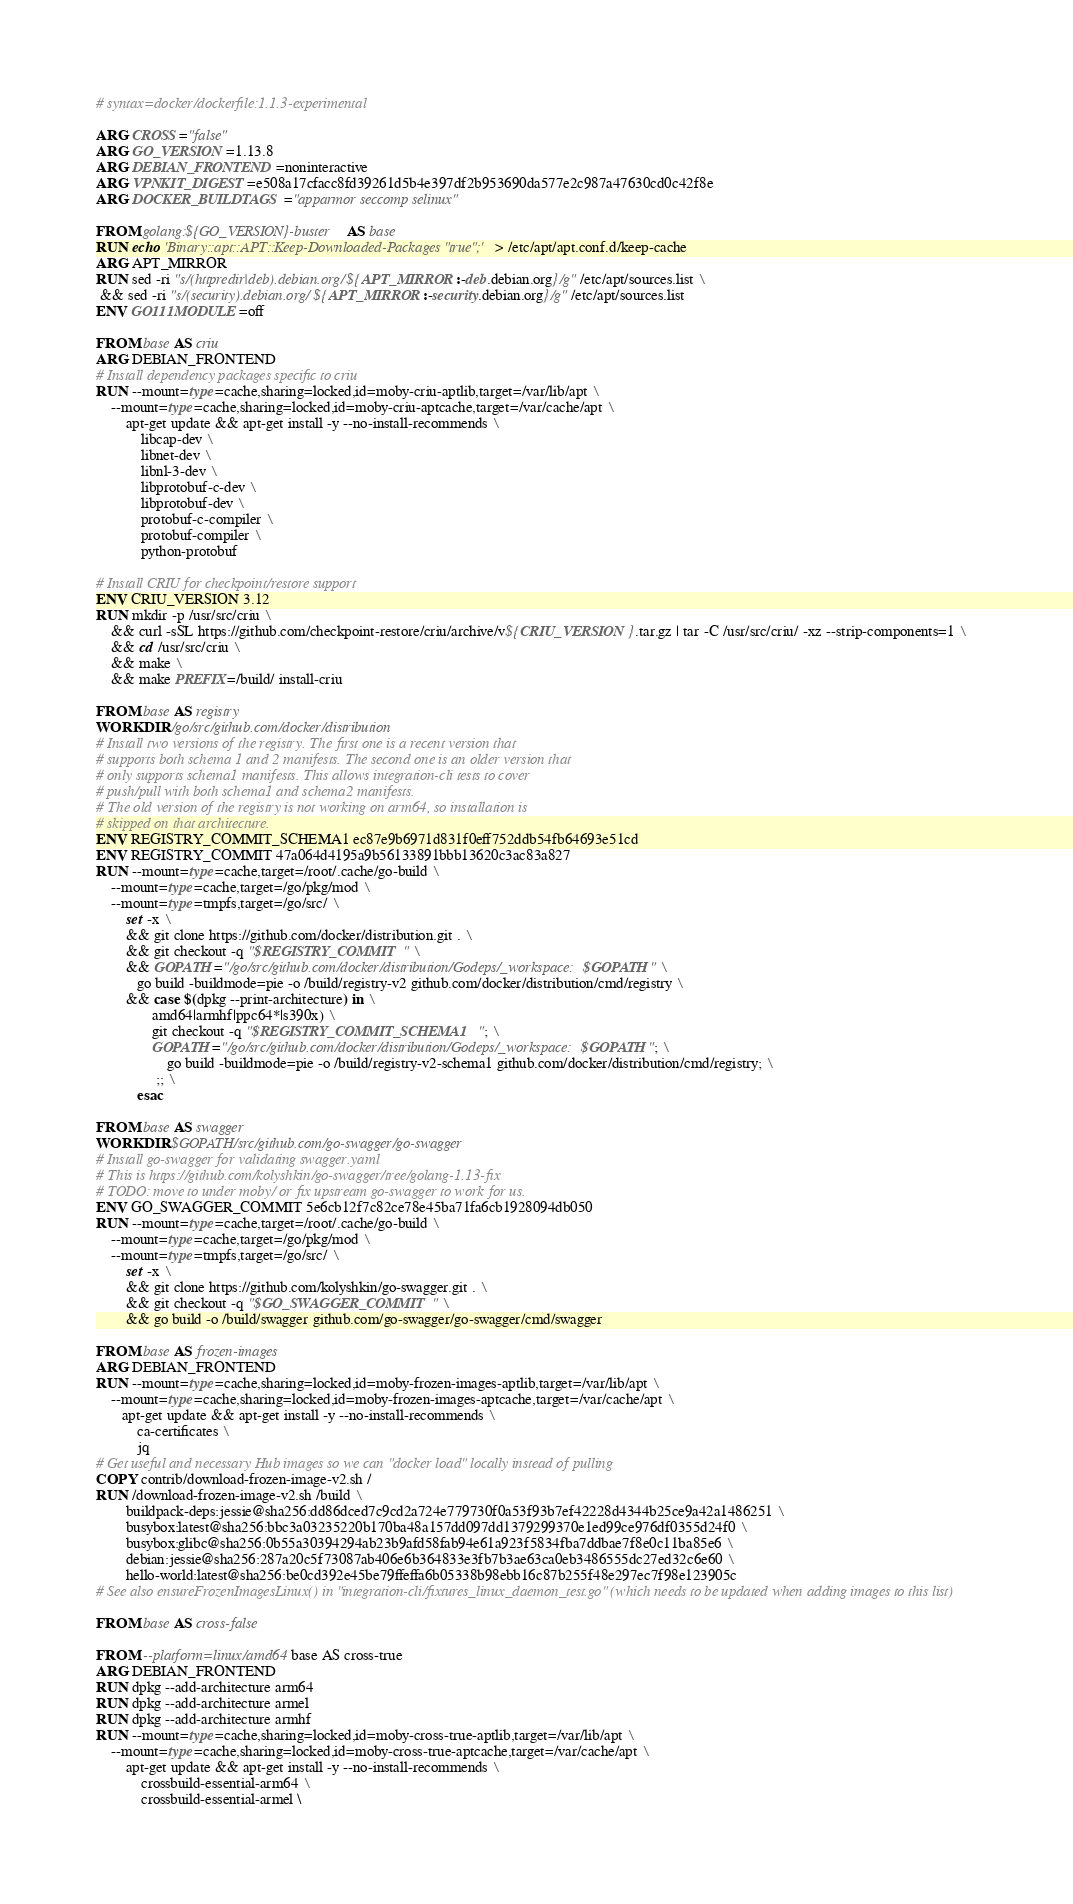<code> <loc_0><loc_0><loc_500><loc_500><_Dockerfile_># syntax=docker/dockerfile:1.1.3-experimental

ARG CROSS="false"
ARG GO_VERSION=1.13.8
ARG DEBIAN_FRONTEND=noninteractive
ARG VPNKIT_DIGEST=e508a17cfacc8fd39261d5b4e397df2b953690da577e2c987a47630cd0c42f8e
ARG DOCKER_BUILDTAGS="apparmor seccomp selinux"

FROM golang:${GO_VERSION}-buster AS base
RUN echo 'Binary::apt::APT::Keep-Downloaded-Packages "true";' > /etc/apt/apt.conf.d/keep-cache
ARG APT_MIRROR
RUN sed -ri "s/(httpredir|deb).debian.org/${APT_MIRROR:-deb.debian.org}/g" /etc/apt/sources.list \
 && sed -ri "s/(security).debian.org/${APT_MIRROR:-security.debian.org}/g" /etc/apt/sources.list
ENV GO111MODULE=off

FROM base AS criu
ARG DEBIAN_FRONTEND
# Install dependency packages specific to criu
RUN --mount=type=cache,sharing=locked,id=moby-criu-aptlib,target=/var/lib/apt \
    --mount=type=cache,sharing=locked,id=moby-criu-aptcache,target=/var/cache/apt \
        apt-get update && apt-get install -y --no-install-recommends \
            libcap-dev \
            libnet-dev \
            libnl-3-dev \
            libprotobuf-c-dev \
            libprotobuf-dev \
            protobuf-c-compiler \
            protobuf-compiler \
            python-protobuf

# Install CRIU for checkpoint/restore support
ENV CRIU_VERSION 3.12
RUN mkdir -p /usr/src/criu \
    && curl -sSL https://github.com/checkpoint-restore/criu/archive/v${CRIU_VERSION}.tar.gz | tar -C /usr/src/criu/ -xz --strip-components=1 \
    && cd /usr/src/criu \
    && make \
    && make PREFIX=/build/ install-criu

FROM base AS registry
WORKDIR /go/src/github.com/docker/distribution
# Install two versions of the registry. The first one is a recent version that
# supports both schema 1 and 2 manifests. The second one is an older version that
# only supports schema1 manifests. This allows integration-cli tests to cover
# push/pull with both schema1 and schema2 manifests.
# The old version of the registry is not working on arm64, so installation is
# skipped on that architecture.
ENV REGISTRY_COMMIT_SCHEMA1 ec87e9b6971d831f0eff752ddb54fb64693e51cd
ENV REGISTRY_COMMIT 47a064d4195a9b56133891bbb13620c3ac83a827
RUN --mount=type=cache,target=/root/.cache/go-build \
    --mount=type=cache,target=/go/pkg/mod \
    --mount=type=tmpfs,target=/go/src/ \
        set -x \
        && git clone https://github.com/docker/distribution.git . \
        && git checkout -q "$REGISTRY_COMMIT" \
        && GOPATH="/go/src/github.com/docker/distribution/Godeps/_workspace:$GOPATH" \
           go build -buildmode=pie -o /build/registry-v2 github.com/docker/distribution/cmd/registry \
        && case $(dpkg --print-architecture) in \
               amd64|armhf|ppc64*|s390x) \
               git checkout -q "$REGISTRY_COMMIT_SCHEMA1"; \
               GOPATH="/go/src/github.com/docker/distribution/Godeps/_workspace:$GOPATH"; \
                   go build -buildmode=pie -o /build/registry-v2-schema1 github.com/docker/distribution/cmd/registry; \
                ;; \
           esac

FROM base AS swagger
WORKDIR $GOPATH/src/github.com/go-swagger/go-swagger
# Install go-swagger for validating swagger.yaml
# This is https://github.com/kolyshkin/go-swagger/tree/golang-1.13-fix
# TODO: move to under moby/ or fix upstream go-swagger to work for us.
ENV GO_SWAGGER_COMMIT 5e6cb12f7c82ce78e45ba71fa6cb1928094db050
RUN --mount=type=cache,target=/root/.cache/go-build \
    --mount=type=cache,target=/go/pkg/mod \
    --mount=type=tmpfs,target=/go/src/ \
        set -x \
        && git clone https://github.com/kolyshkin/go-swagger.git . \
        && git checkout -q "$GO_SWAGGER_COMMIT" \
        && go build -o /build/swagger github.com/go-swagger/go-swagger/cmd/swagger

FROM base AS frozen-images
ARG DEBIAN_FRONTEND
RUN --mount=type=cache,sharing=locked,id=moby-frozen-images-aptlib,target=/var/lib/apt \
    --mount=type=cache,sharing=locked,id=moby-frozen-images-aptcache,target=/var/cache/apt \
       apt-get update && apt-get install -y --no-install-recommends \
           ca-certificates \
           jq
# Get useful and necessary Hub images so we can "docker load" locally instead of pulling
COPY contrib/download-frozen-image-v2.sh /
RUN /download-frozen-image-v2.sh /build \
        buildpack-deps:jessie@sha256:dd86dced7c9cd2a724e779730f0a53f93b7ef42228d4344b25ce9a42a1486251 \
        busybox:latest@sha256:bbc3a03235220b170ba48a157dd097dd1379299370e1ed99ce976df0355d24f0 \
        busybox:glibc@sha256:0b55a30394294ab23b9afd58fab94e61a923f5834fba7ddbae7f8e0c11ba85e6 \
        debian:jessie@sha256:287a20c5f73087ab406e6b364833e3fb7b3ae63ca0eb3486555dc27ed32c6e60 \
        hello-world:latest@sha256:be0cd392e45be79ffeffa6b05338b98ebb16c87b255f48e297ec7f98e123905c
# See also ensureFrozenImagesLinux() in "integration-cli/fixtures_linux_daemon_test.go" (which needs to be updated when adding images to this list)

FROM base AS cross-false

FROM --platform=linux/amd64 base AS cross-true
ARG DEBIAN_FRONTEND
RUN dpkg --add-architecture arm64
RUN dpkg --add-architecture armel
RUN dpkg --add-architecture armhf
RUN --mount=type=cache,sharing=locked,id=moby-cross-true-aptlib,target=/var/lib/apt \
    --mount=type=cache,sharing=locked,id=moby-cross-true-aptcache,target=/var/cache/apt \
        apt-get update && apt-get install -y --no-install-recommends \
            crossbuild-essential-arm64 \
            crossbuild-essential-armel \</code> 